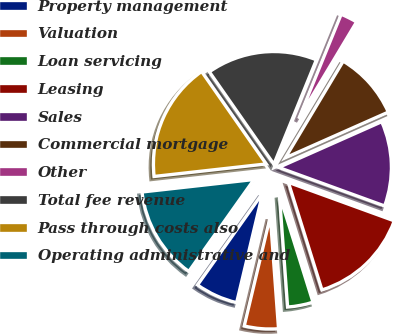<chart> <loc_0><loc_0><loc_500><loc_500><pie_chart><fcel>Property management<fcel>Valuation<fcel>Loan servicing<fcel>Leasing<fcel>Sales<fcel>Commercial mortgage<fcel>Other<fcel>Total fee revenue<fcel>Pass through costs also<fcel>Operating administrative and<nl><fcel>6.1%<fcel>4.88%<fcel>3.66%<fcel>14.63%<fcel>12.2%<fcel>9.76%<fcel>2.44%<fcel>15.85%<fcel>17.07%<fcel>13.41%<nl></chart> 